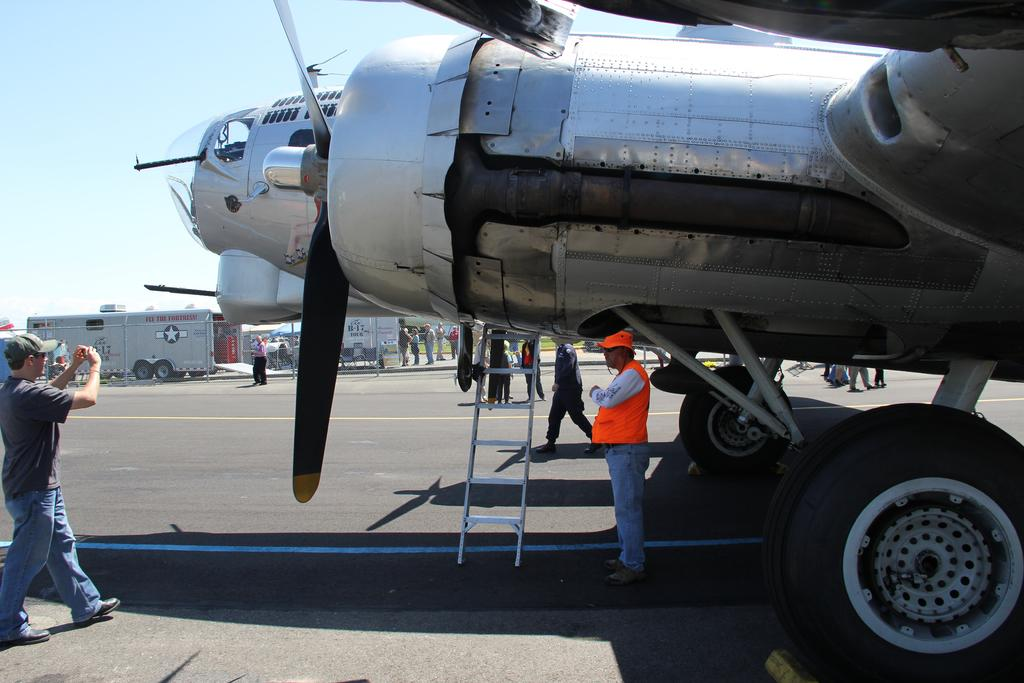What is the unusual object on the road in the image? There is an aeroplane on the road in the image. What can be seen in the background of the image? There are people, vehicles, and the sky visible in the background of the image. What type of cushion is being used by the aeroplane to skate on the road? There is no cushion or skating activity depicted in the image; the aeroplane is simply on the road. 